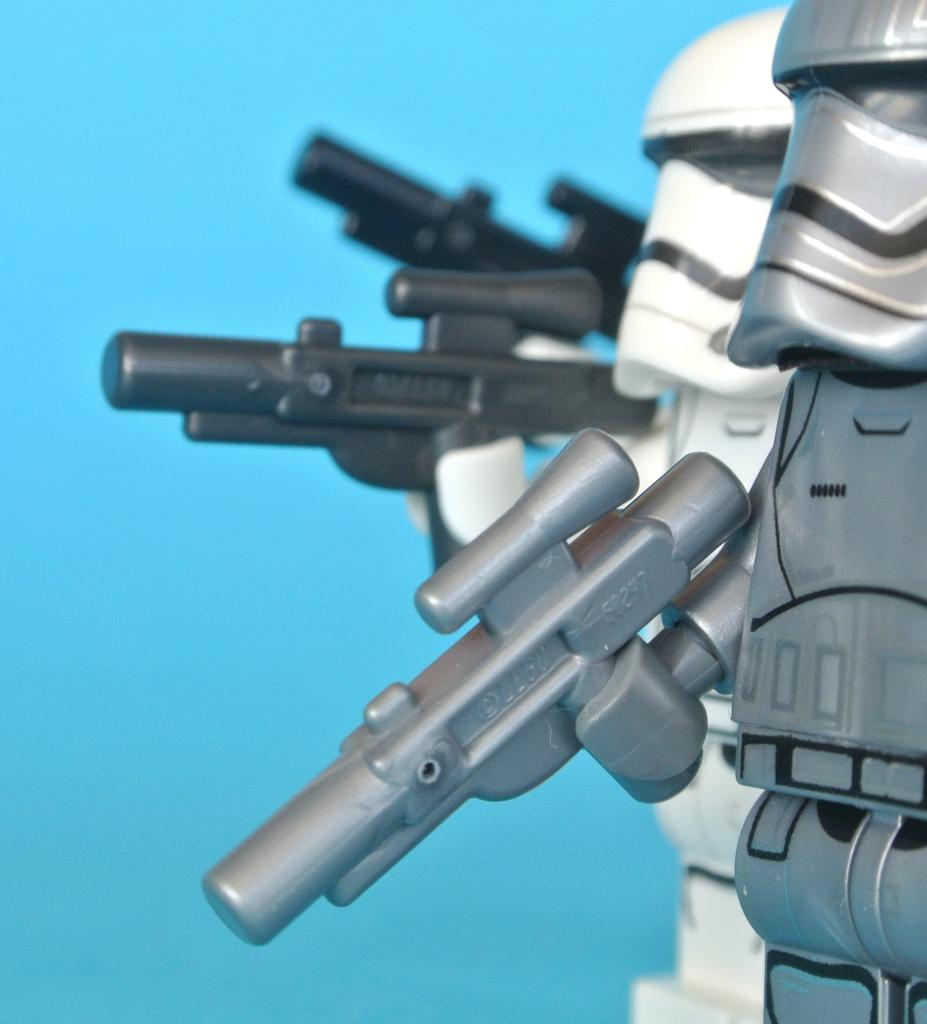What type of objects can be seen in the image? There are toys in the image. What are the toys doing in the image? The toys are holding weapons. What colors are the toys in the image? The toys are in black, white, and silver colors. What color is the background of the image? The background of the image is blue. What type of snow can be seen falling in the image? There is no snow present in the image. How does the acoustics of the toys affect the sound in the image? There is no information about the acoustics of the toys or any sound in the image. 